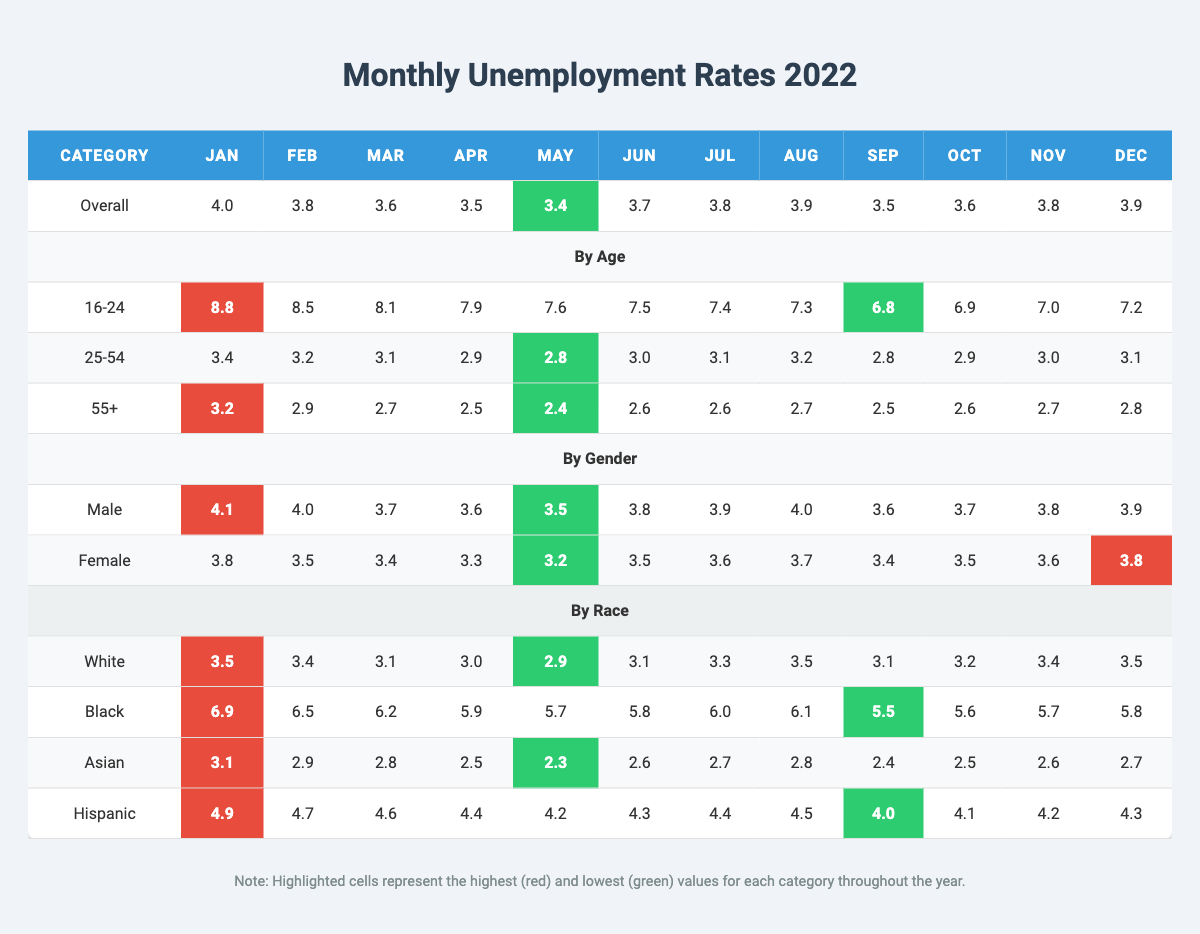What was the overall unemployment rate in December 2022? Referring to the "Overall" row under the "Dec" column, the unemployment rate is 3.9%.
Answer: 3.9 Which age group had the highest unemployment rate in January 2022? Looking at the "By Age" section for January, the 16-24 age group had the highest rate at 8.8%.
Answer: 16-24 What is the unemployment rate for Hispanic individuals in March 2022? By checking the "Hispanic" row in the "Mar" column, the rate is 4.6%.
Answer: 4.6 Which month had the lowest unemployment rate for the age group 55+? The lowest rate for the 55+ age group is found in May at 2.4%, which can be seen in the row for that age group.
Answer: May What is the average unemployment rate for the age group 25-54 throughout 2022? Calculating the average: (3.4 + 3.2 + 3.1 + 2.9 + 2.8 + 3.0 + 3.1 + 3.2 + 2.8 + 2.9 + 3.0 + 3.1) = 36.5, and then dividing by 12 gives us an average of 3.04.
Answer: 3.04 Was the unemployment rate for males higher in June than in September? By checking the "Male" row, June shows a rate of 3.8% while September shows 3.6%, hence yes, June's rate was higher.
Answer: Yes In which month did the Black demographic experience the highest unemployment rate? The "Black" row shows the highest unemployment rate in January at 6.9%.
Answer: January How many months had an overall unemployment rate below 3.5% in 2022? The rates below 3.5% were found in May, April, March, and so on. The total count is 5 months: May, April, March, February, and October produce rates below that threshold.
Answer: 5 Determine the difference in unemployment rates between White and Hispanic individuals in October 2022. In October, White's rate is 3.2% and Hispanic's is 4.1%; the difference is 4.1 - 3.2 = 0.9%.
Answer: 0.9 Which gender had a consistently lower unemployment rate throughout the year? Comparing the rates for males and females month by month reveals that females had lower rates in all months except January, thus females had a lower overall unemployment rate throughout the year.
Answer: Females What trend can be observed for the unemployment rate in the age group 16-24 from January to December? Upon reviewing the "16-24" row, the unemployment rate shows a decreasing trend from 8.8% in January to 7.2% in December, indicating an overall decline over the year.
Answer: Decreasing trend 